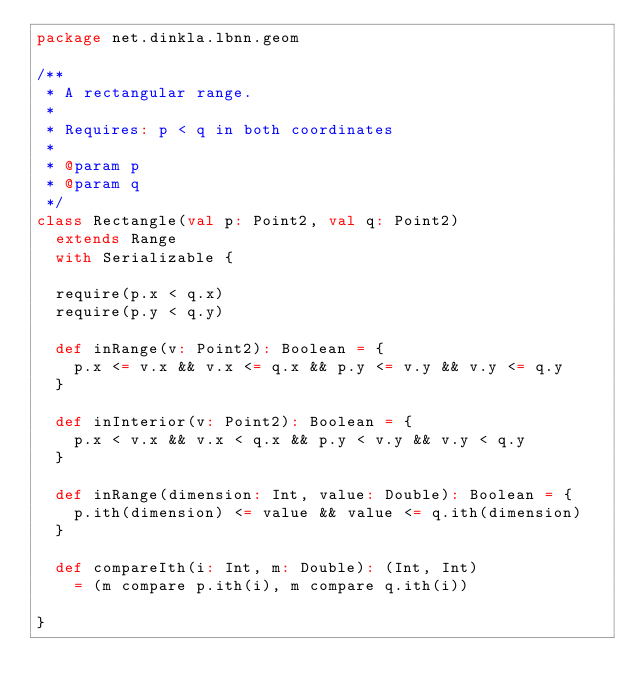<code> <loc_0><loc_0><loc_500><loc_500><_Scala_>package net.dinkla.lbnn.geom

/**
 * A rectangular range.
 *
 * Requires: p < q in both coordinates
 *
 * @param p
 * @param q
 */
class Rectangle(val p: Point2, val q: Point2)
  extends Range
  with Serializable {

  require(p.x < q.x)
  require(p.y < q.y)

  def inRange(v: Point2): Boolean = {
    p.x <= v.x && v.x <= q.x && p.y <= v.y && v.y <= q.y
  }

  def inInterior(v: Point2): Boolean = {
    p.x < v.x && v.x < q.x && p.y < v.y && v.y < q.y
  }

  def inRange(dimension: Int, value: Double): Boolean = {
    p.ith(dimension) <= value && value <= q.ith(dimension)
  }

  def compareIth(i: Int, m: Double): (Int, Int)
    = (m compare p.ith(i), m compare q.ith(i))

}
</code> 